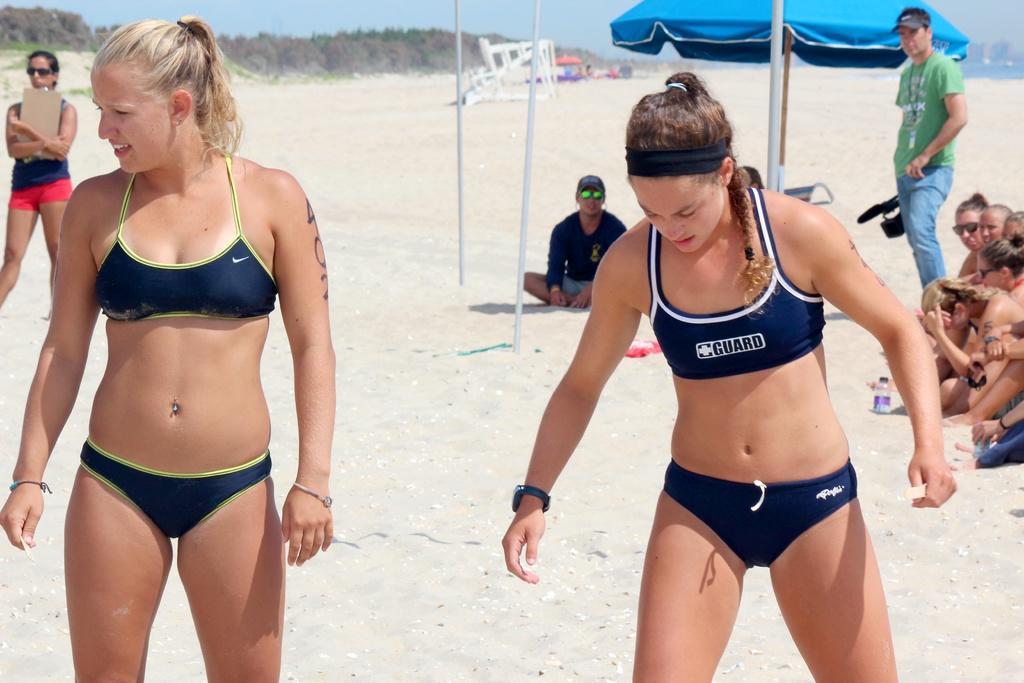In one or two sentences, can you explain what this image depicts? In the foreground of the picture there are women. In the background there are women, person holding camera, umbrella, poles and a woman holding pad. In the center of the background there is a person sitting in sand. In the background there are trees, sand, people, umbrella and various objects. In the background towards right there is a water body and buildings. 